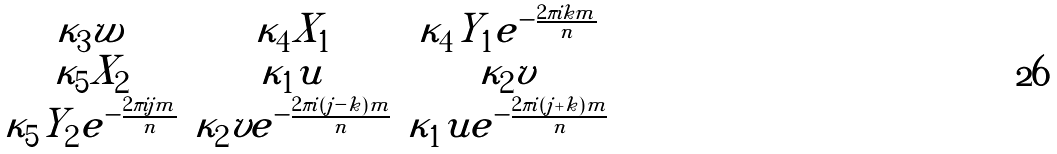<formula> <loc_0><loc_0><loc_500><loc_500>\begin{matrix} \kappa _ { 3 } w & \kappa _ { 4 } X _ { 1 } & \kappa _ { 4 } Y _ { 1 } e ^ { - \frac { 2 \pi i k m } { n } } \\ \kappa _ { 5 } X _ { 2 } & \kappa _ { 1 } u & \kappa _ { 2 } v \\ \kappa _ { 5 } Y _ { 2 } e ^ { - \frac { 2 \pi i j m } { n } } & \kappa _ { 2 } v e ^ { - \frac { 2 \pi i ( j - k ) m } { n } } & \kappa _ { 1 } u e ^ { - \frac { 2 \pi i ( j + k ) m } { n } } \end{matrix}</formula> 